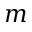<formula> <loc_0><loc_0><loc_500><loc_500>m</formula> 